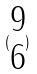<formula> <loc_0><loc_0><loc_500><loc_500>( \begin{matrix} 9 \\ 6 \end{matrix} )</formula> 